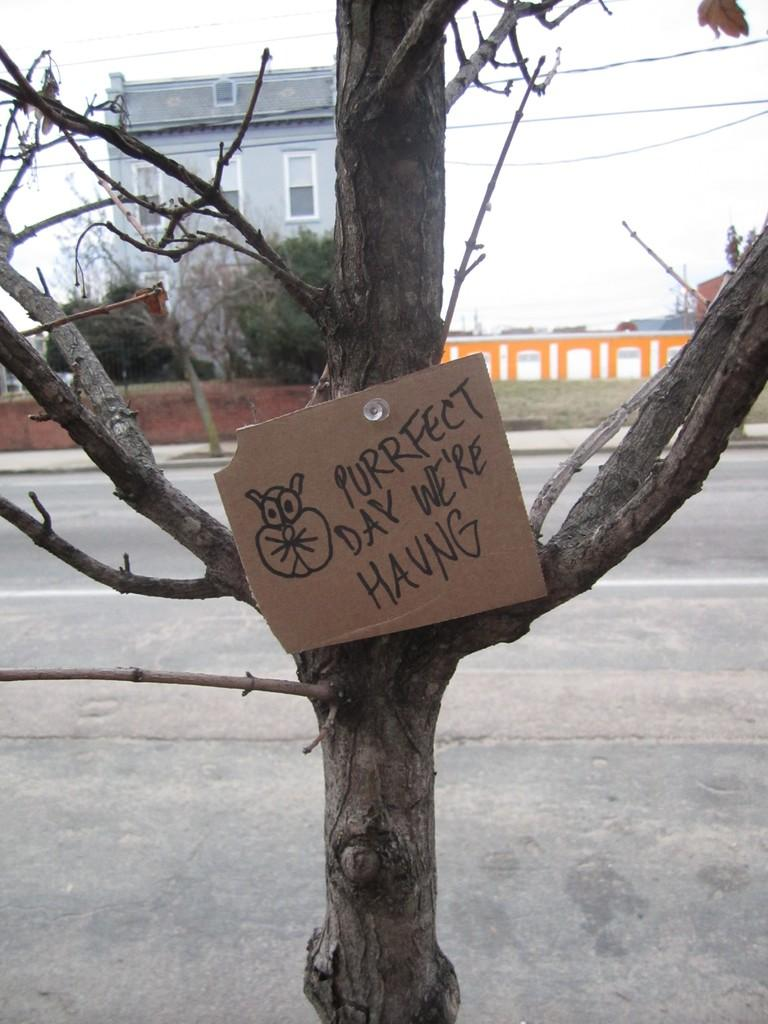What material is the object in the image made of? There is a cardboard in the image. What type of natural environment is visible in the image? There are trees in the image. What man-made structure can be seen in the image? There is a road in the image. What architectural feature is present in the image? There is a wall in the image. What can be seen in the background of the image? There is a building and the sky visible in the background of the image. How many cakes are being mined by the stranger in the image? There is no stranger or cakes present in the image. What type of mine is visible in the image? There is no mine present in the image. 